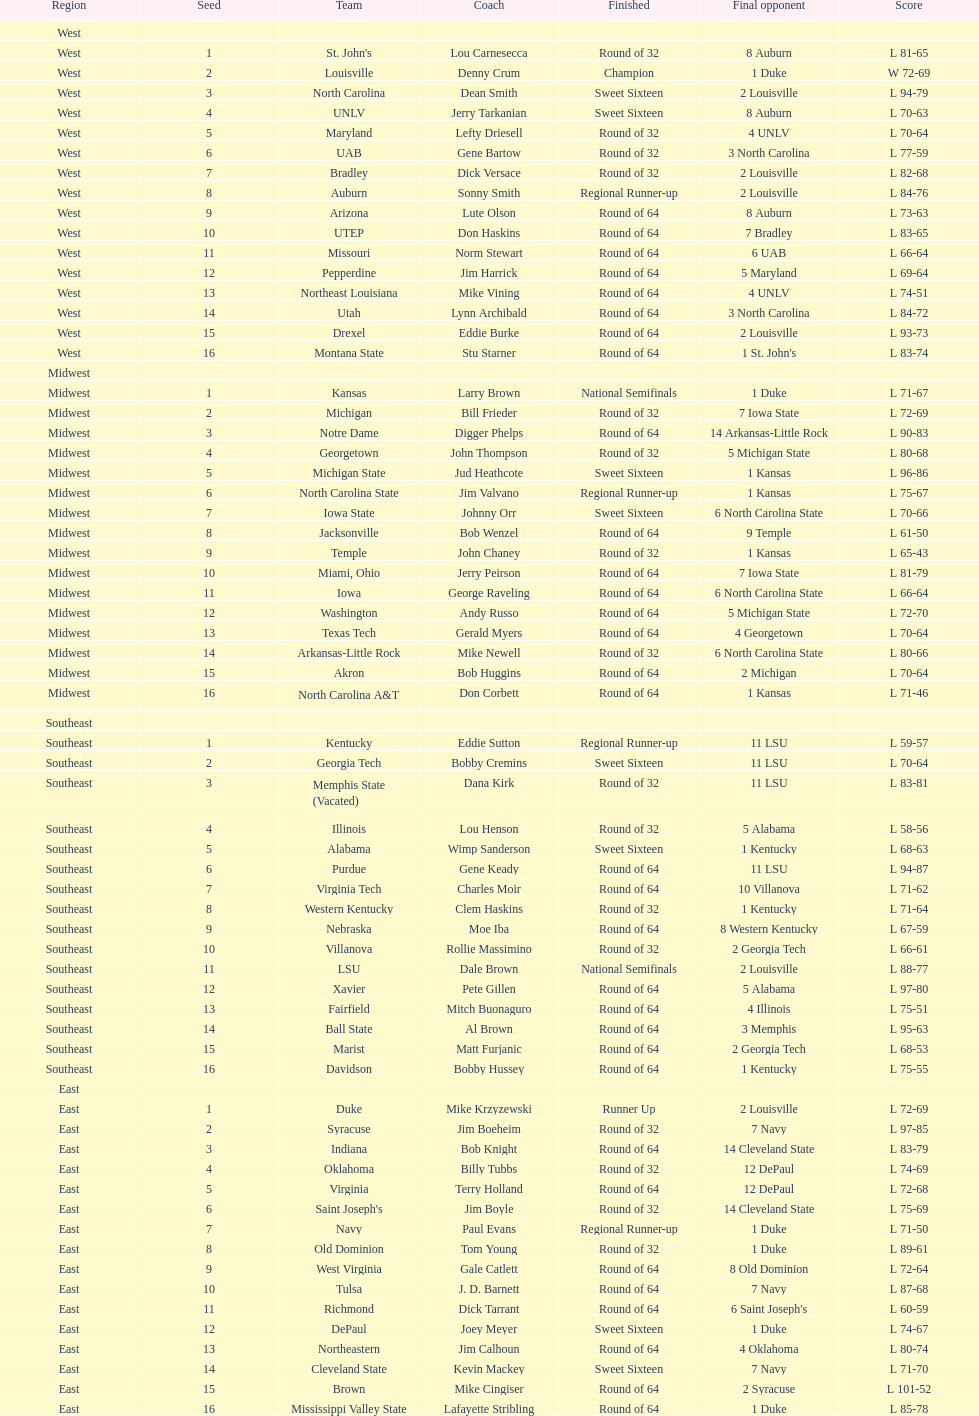Which team went finished later in the tournament, st. john's or north carolina a&t? North Carolina A&T. 